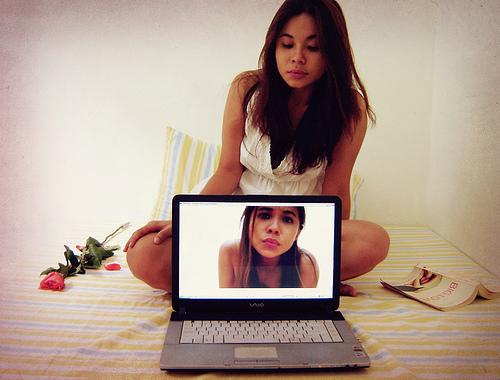Are there any flowers on the bed?
Be succinct. Yes. Is the girl smiling?
Write a very short answer. No. Is the laptop open or closed?
Answer briefly. Open. 